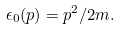Convert formula to latex. <formula><loc_0><loc_0><loc_500><loc_500>\epsilon _ { 0 } ( p ) = p ^ { 2 } / 2 m .</formula> 